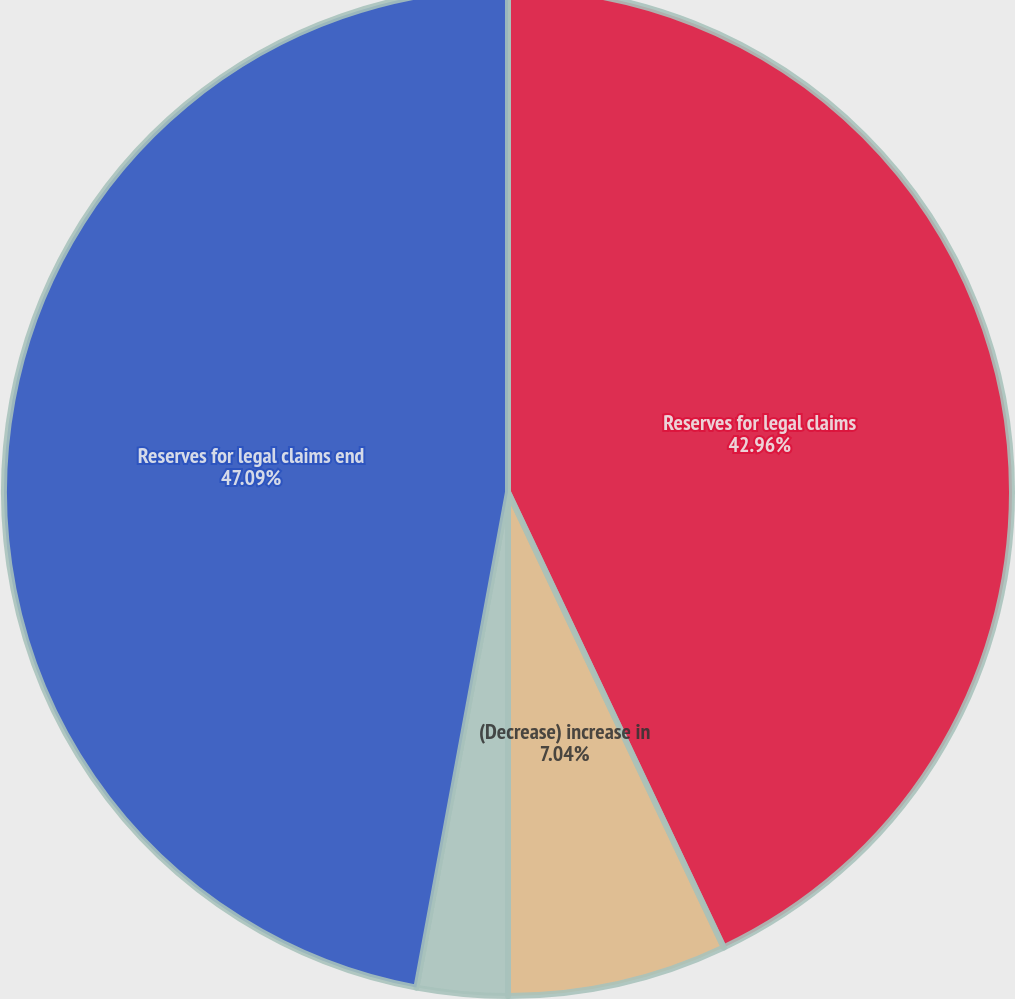<chart> <loc_0><loc_0><loc_500><loc_500><pie_chart><fcel>Reserves for legal claims<fcel>(Decrease) increase in<fcel>Payments<fcel>Reserves for legal claims end<nl><fcel>42.96%<fcel>7.04%<fcel>2.91%<fcel>47.09%<nl></chart> 